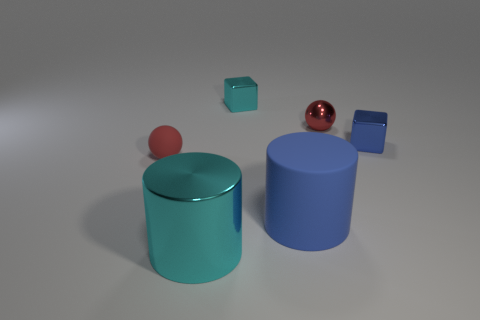There is a shiny block right of the big blue thing; is its color the same as the rubber sphere? no 